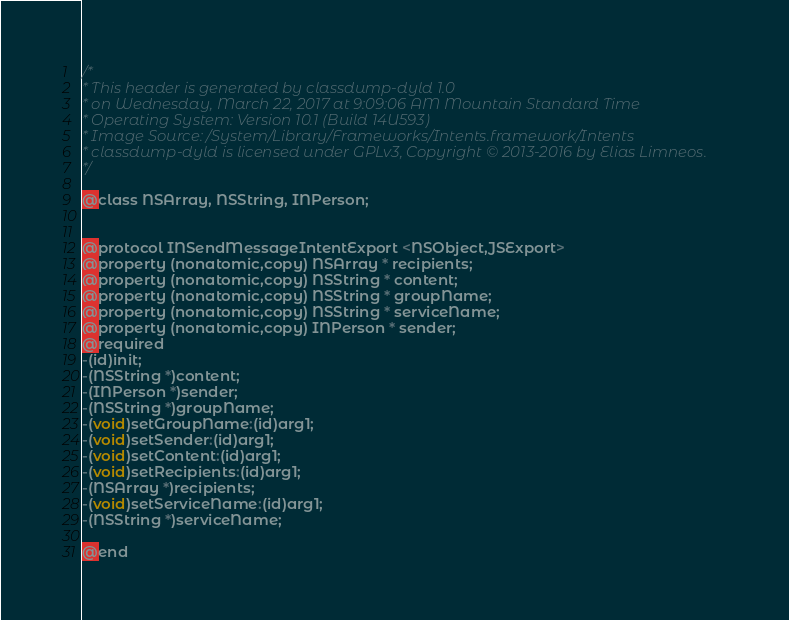Convert code to text. <code><loc_0><loc_0><loc_500><loc_500><_C_>/*
* This header is generated by classdump-dyld 1.0
* on Wednesday, March 22, 2017 at 9:09:06 AM Mountain Standard Time
* Operating System: Version 10.1 (Build 14U593)
* Image Source: /System/Library/Frameworks/Intents.framework/Intents
* classdump-dyld is licensed under GPLv3, Copyright © 2013-2016 by Elias Limneos.
*/

@class NSArray, NSString, INPerson;


@protocol INSendMessageIntentExport <NSObject,JSExport>
@property (nonatomic,copy) NSArray * recipients; 
@property (nonatomic,copy) NSString * content; 
@property (nonatomic,copy) NSString * groupName; 
@property (nonatomic,copy) NSString * serviceName; 
@property (nonatomic,copy) INPerson * sender; 
@required
-(id)init;
-(NSString *)content;
-(INPerson *)sender;
-(NSString *)groupName;
-(void)setGroupName:(id)arg1;
-(void)setSender:(id)arg1;
-(void)setContent:(id)arg1;
-(void)setRecipients:(id)arg1;
-(NSArray *)recipients;
-(void)setServiceName:(id)arg1;
-(NSString *)serviceName;

@end

</code> 